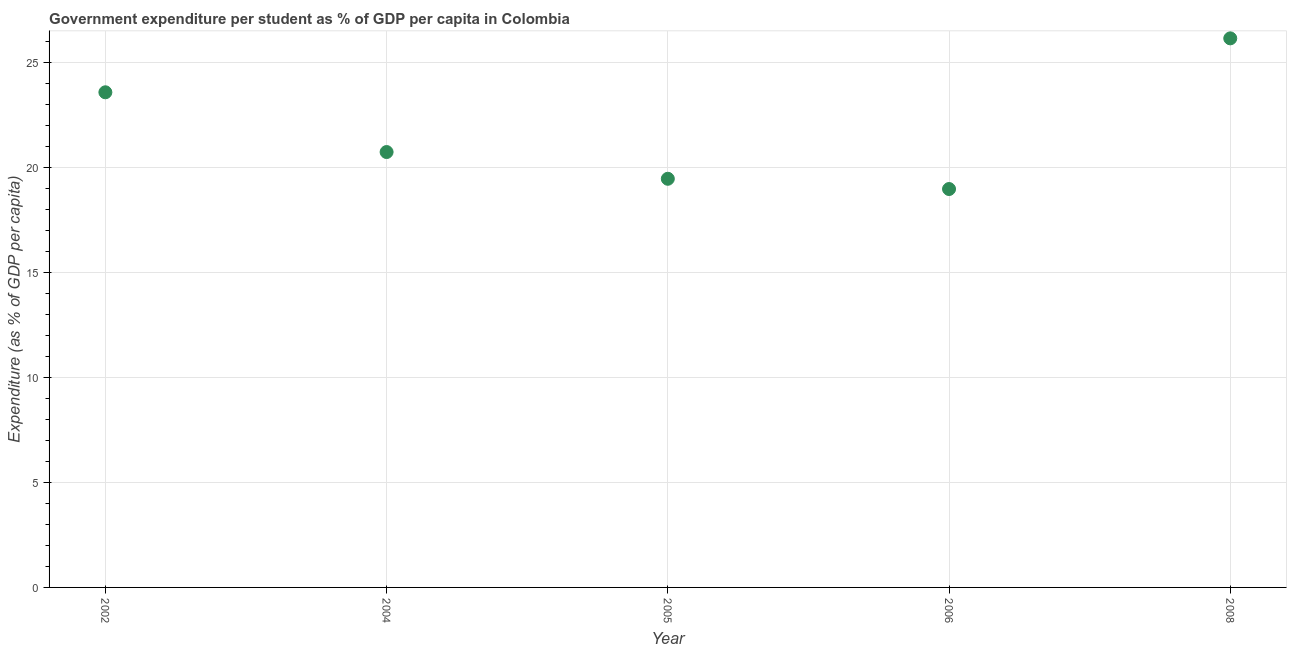What is the government expenditure per student in 2004?
Your response must be concise. 20.75. Across all years, what is the maximum government expenditure per student?
Make the answer very short. 26.17. Across all years, what is the minimum government expenditure per student?
Ensure brevity in your answer.  18.99. In which year was the government expenditure per student maximum?
Offer a very short reply. 2008. What is the sum of the government expenditure per student?
Your response must be concise. 108.99. What is the difference between the government expenditure per student in 2002 and 2005?
Offer a terse response. 4.12. What is the average government expenditure per student per year?
Provide a succinct answer. 21.8. What is the median government expenditure per student?
Keep it short and to the point. 20.75. Do a majority of the years between 2006 and 2002 (inclusive) have government expenditure per student greater than 1 %?
Ensure brevity in your answer.  Yes. What is the ratio of the government expenditure per student in 2002 to that in 2006?
Keep it short and to the point. 1.24. Is the government expenditure per student in 2006 less than that in 2008?
Your answer should be compact. Yes. Is the difference between the government expenditure per student in 2005 and 2008 greater than the difference between any two years?
Keep it short and to the point. No. What is the difference between the highest and the second highest government expenditure per student?
Offer a very short reply. 2.57. Is the sum of the government expenditure per student in 2002 and 2008 greater than the maximum government expenditure per student across all years?
Give a very brief answer. Yes. What is the difference between the highest and the lowest government expenditure per student?
Give a very brief answer. 7.18. Does the government expenditure per student monotonically increase over the years?
Offer a terse response. No. How many dotlines are there?
Provide a short and direct response. 1. What is the difference between two consecutive major ticks on the Y-axis?
Give a very brief answer. 5. Does the graph contain grids?
Give a very brief answer. Yes. What is the title of the graph?
Provide a succinct answer. Government expenditure per student as % of GDP per capita in Colombia. What is the label or title of the Y-axis?
Offer a terse response. Expenditure (as % of GDP per capita). What is the Expenditure (as % of GDP per capita) in 2002?
Give a very brief answer. 23.6. What is the Expenditure (as % of GDP per capita) in 2004?
Offer a very short reply. 20.75. What is the Expenditure (as % of GDP per capita) in 2005?
Provide a succinct answer. 19.48. What is the Expenditure (as % of GDP per capita) in 2006?
Ensure brevity in your answer.  18.99. What is the Expenditure (as % of GDP per capita) in 2008?
Offer a terse response. 26.17. What is the difference between the Expenditure (as % of GDP per capita) in 2002 and 2004?
Your response must be concise. 2.85. What is the difference between the Expenditure (as % of GDP per capita) in 2002 and 2005?
Your answer should be very brief. 4.12. What is the difference between the Expenditure (as % of GDP per capita) in 2002 and 2006?
Provide a short and direct response. 4.61. What is the difference between the Expenditure (as % of GDP per capita) in 2002 and 2008?
Your answer should be very brief. -2.57. What is the difference between the Expenditure (as % of GDP per capita) in 2004 and 2005?
Give a very brief answer. 1.27. What is the difference between the Expenditure (as % of GDP per capita) in 2004 and 2006?
Give a very brief answer. 1.76. What is the difference between the Expenditure (as % of GDP per capita) in 2004 and 2008?
Provide a short and direct response. -5.42. What is the difference between the Expenditure (as % of GDP per capita) in 2005 and 2006?
Offer a terse response. 0.49. What is the difference between the Expenditure (as % of GDP per capita) in 2005 and 2008?
Your response must be concise. -6.69. What is the difference between the Expenditure (as % of GDP per capita) in 2006 and 2008?
Your answer should be very brief. -7.18. What is the ratio of the Expenditure (as % of GDP per capita) in 2002 to that in 2004?
Make the answer very short. 1.14. What is the ratio of the Expenditure (as % of GDP per capita) in 2002 to that in 2005?
Provide a succinct answer. 1.21. What is the ratio of the Expenditure (as % of GDP per capita) in 2002 to that in 2006?
Keep it short and to the point. 1.24. What is the ratio of the Expenditure (as % of GDP per capita) in 2002 to that in 2008?
Offer a very short reply. 0.9. What is the ratio of the Expenditure (as % of GDP per capita) in 2004 to that in 2005?
Your answer should be very brief. 1.06. What is the ratio of the Expenditure (as % of GDP per capita) in 2004 to that in 2006?
Give a very brief answer. 1.09. What is the ratio of the Expenditure (as % of GDP per capita) in 2004 to that in 2008?
Provide a succinct answer. 0.79. What is the ratio of the Expenditure (as % of GDP per capita) in 2005 to that in 2008?
Give a very brief answer. 0.74. What is the ratio of the Expenditure (as % of GDP per capita) in 2006 to that in 2008?
Offer a terse response. 0.73. 